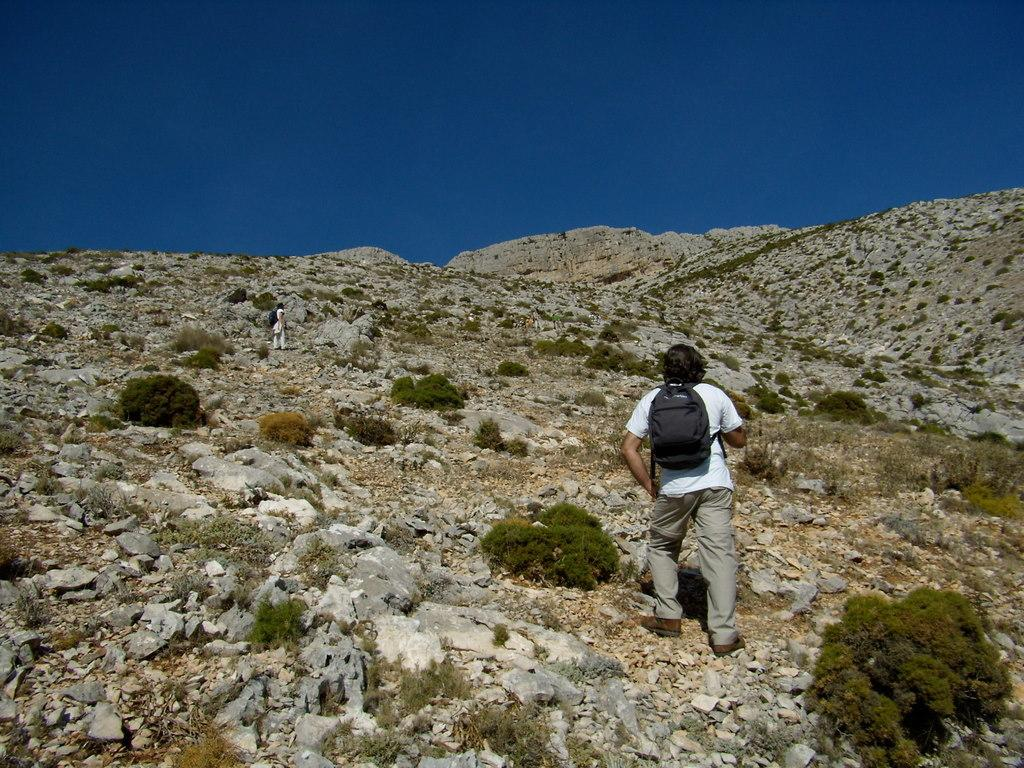What is the main subject of the image? The image depicts a mountain. Are there any people present on the mountain? Yes, there are two persons standing on the mountain. What else can be seen on the mountain besides the people? There are plants on the mountain. What is visible at the top of the mountain in the image? The sky is visible at the top of the mountain in the image. What type of pencil can be seen in the image? There is no pencil present in the image; it features a mountain with two persons and plants. 